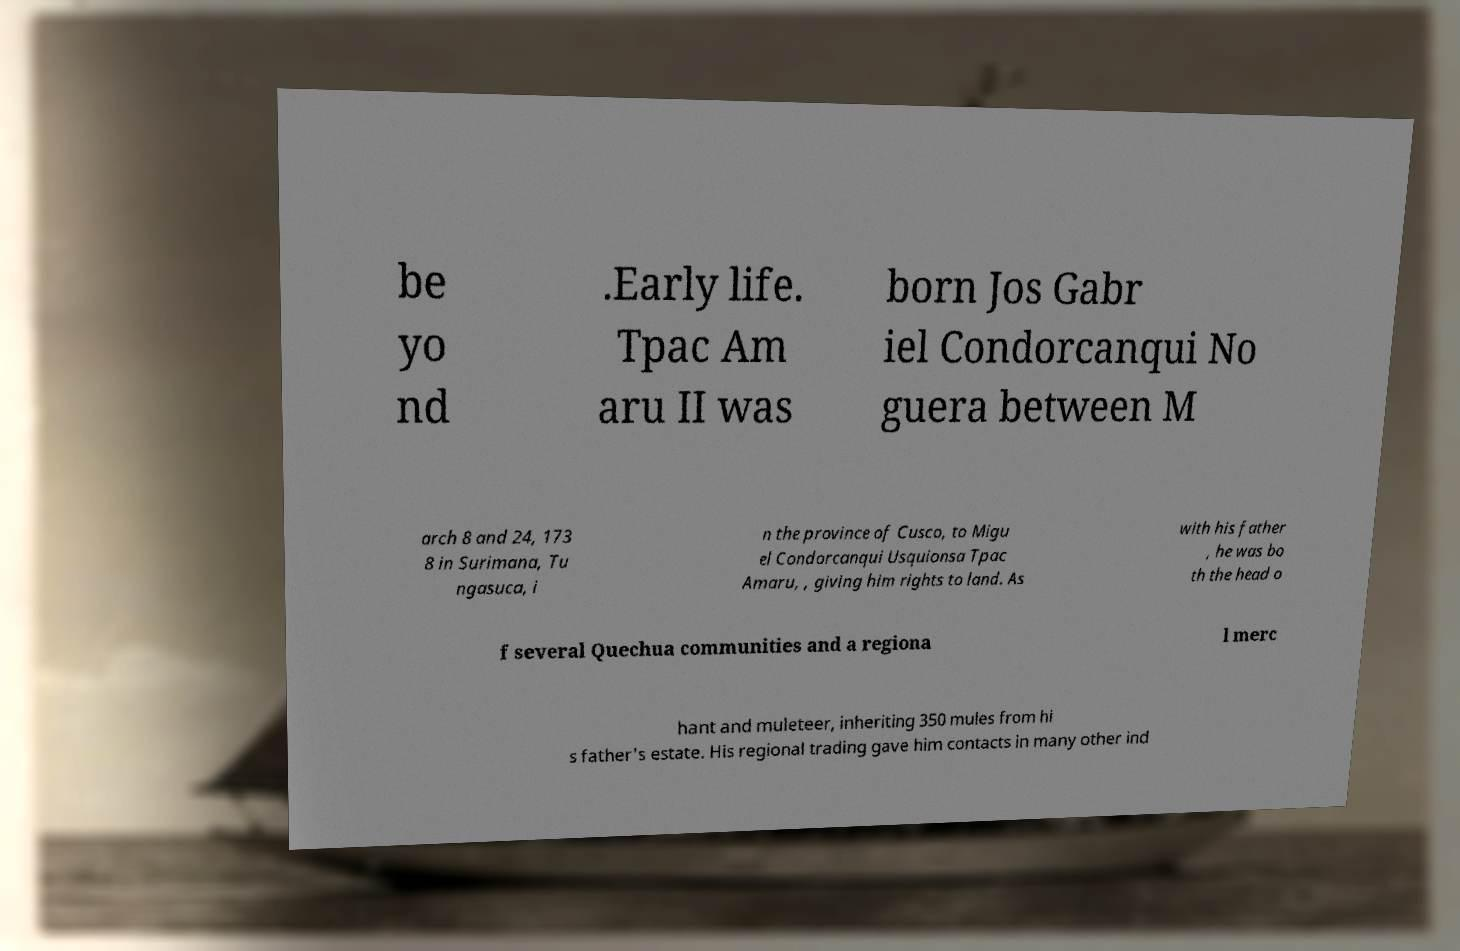For documentation purposes, I need the text within this image transcribed. Could you provide that? be yo nd .Early life. Tpac Am aru II was born Jos Gabr iel Condorcanqui No guera between M arch 8 and 24, 173 8 in Surimana, Tu ngasuca, i n the province of Cusco, to Migu el Condorcanqui Usquionsa Tpac Amaru, , giving him rights to land. As with his father , he was bo th the head o f several Quechua communities and a regiona l merc hant and muleteer, inheriting 350 mules from hi s father's estate. His regional trading gave him contacts in many other ind 